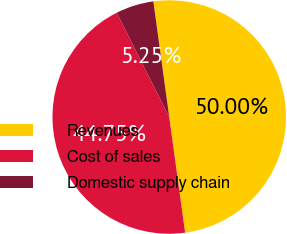<chart> <loc_0><loc_0><loc_500><loc_500><pie_chart><fcel>Revenues<fcel>Cost of sales<fcel>Domestic supply chain<nl><fcel>50.0%<fcel>44.75%<fcel>5.25%<nl></chart> 